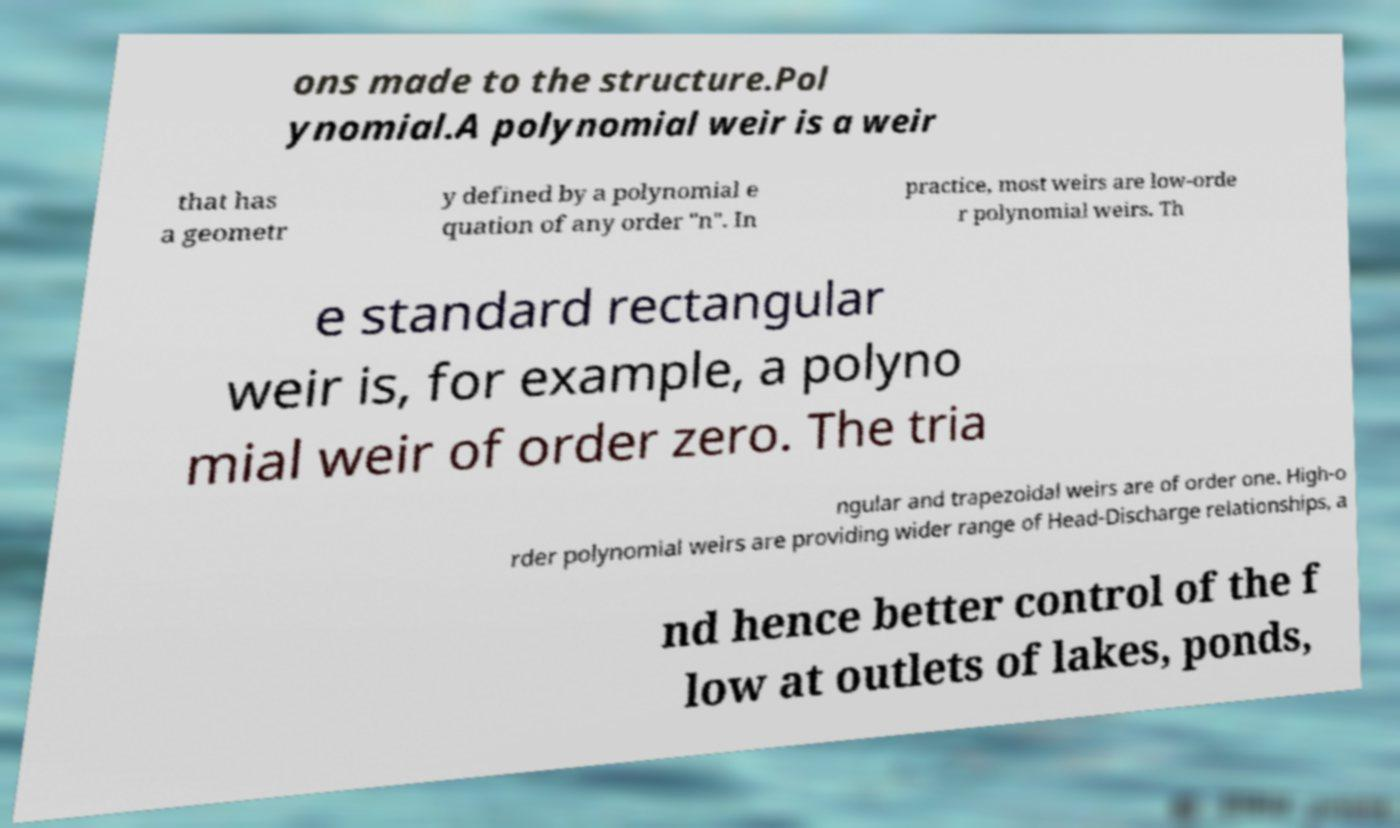For documentation purposes, I need the text within this image transcribed. Could you provide that? ons made to the structure.Pol ynomial.A polynomial weir is a weir that has a geometr y defined by a polynomial e quation of any order "n". In practice, most weirs are low-orde r polynomial weirs. Th e standard rectangular weir is, for example, a polyno mial weir of order zero. The tria ngular and trapezoidal weirs are of order one. High-o rder polynomial weirs are providing wider range of Head-Discharge relationships, a nd hence better control of the f low at outlets of lakes, ponds, 